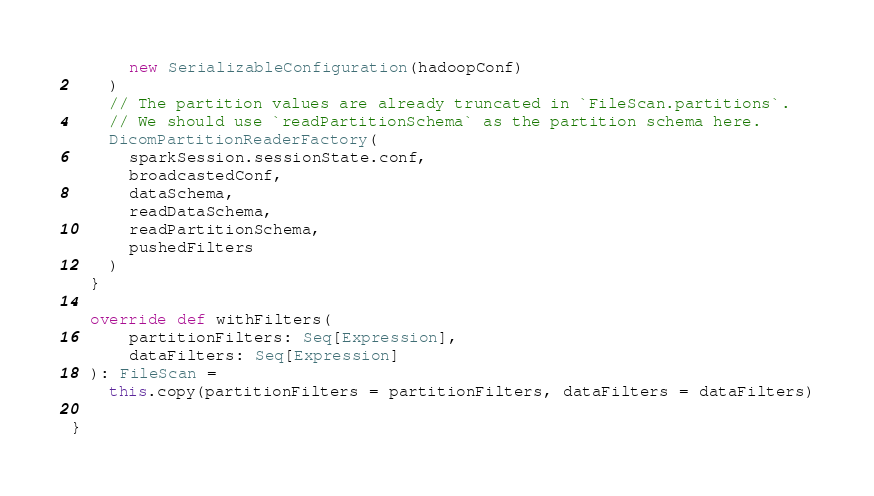<code> <loc_0><loc_0><loc_500><loc_500><_Scala_>      new SerializableConfiguration(hadoopConf)
    )
    // The partition values are already truncated in `FileScan.partitions`.
    // We should use `readPartitionSchema` as the partition schema here.
    DicomPartitionReaderFactory(
      sparkSession.sessionState.conf,
      broadcastedConf,
      dataSchema,
      readDataSchema,
      readPartitionSchema,
      pushedFilters
    )
  }

  override def withFilters(
      partitionFilters: Seq[Expression],
      dataFilters: Seq[Expression]
  ): FileScan =
    this.copy(partitionFilters = partitionFilters, dataFilters = dataFilters)

}
</code> 